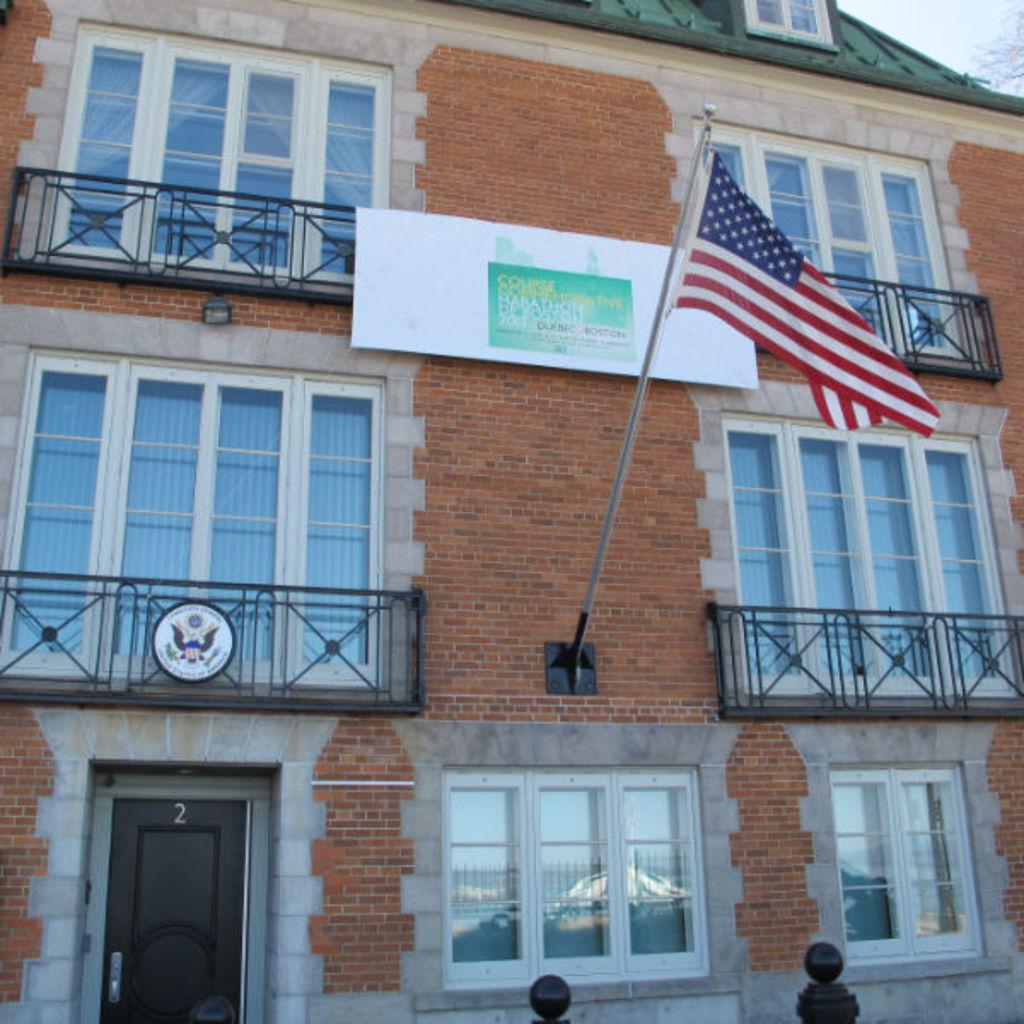What type of structure is present in the image? There is a building in the image. What features can be observed on the building? The building has windows and railing. What additional object is present near the building? There is a flag in the image. What is associated with the building and can be seen in the image? There is a board associated with the building. What can be seen through the windows of the building? The sky and a vehicle are visible through the glass of a window. How many trains are visible through the windows of the building? There are no trains visible through the windows of the building in the image. What type of sticks are being used to support the building? There are no sticks visible in the image, and the building does not appear to be supported by any sticks. 